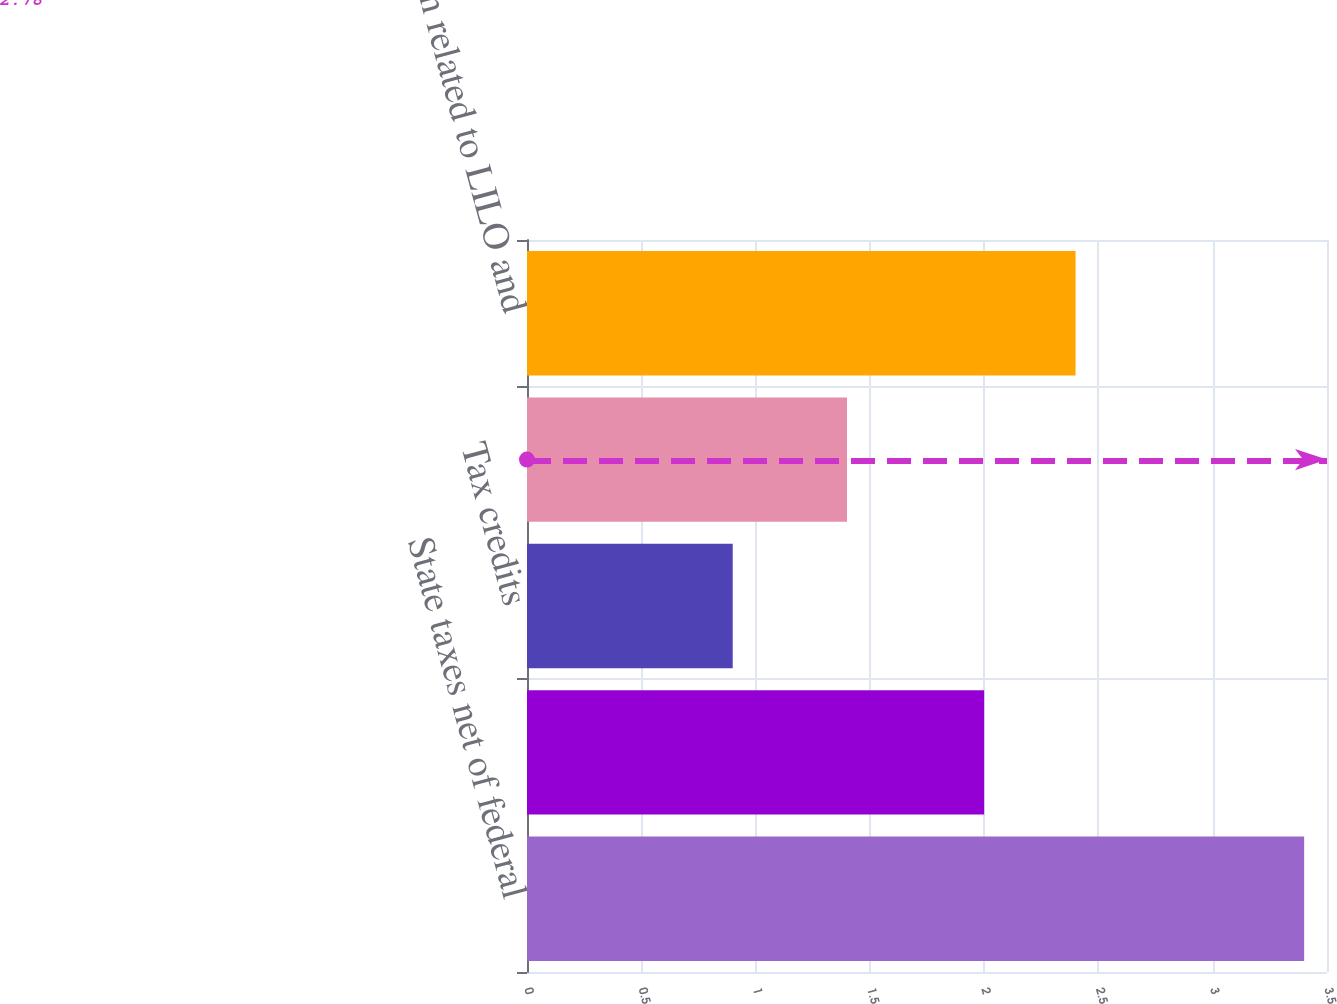Convert chart. <chart><loc_0><loc_0><loc_500><loc_500><bar_chart><fcel>State taxes net of federal<fcel>Tax-exempt income<fcel>Tax credits<fcel>Foreign tax differential<fcel>Provision related to LILO and<nl><fcel>3.4<fcel>2<fcel>0.9<fcel>1.4<fcel>2.4<nl></chart> 